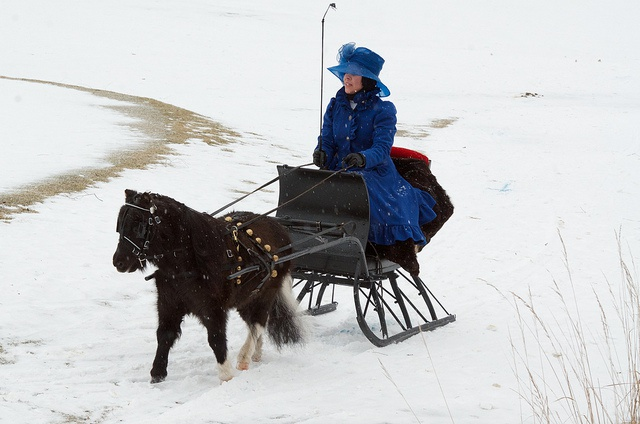Describe the objects in this image and their specific colors. I can see horse in white, black, darkgray, gray, and lightgray tones and people in white, navy, black, blue, and darkblue tones in this image. 